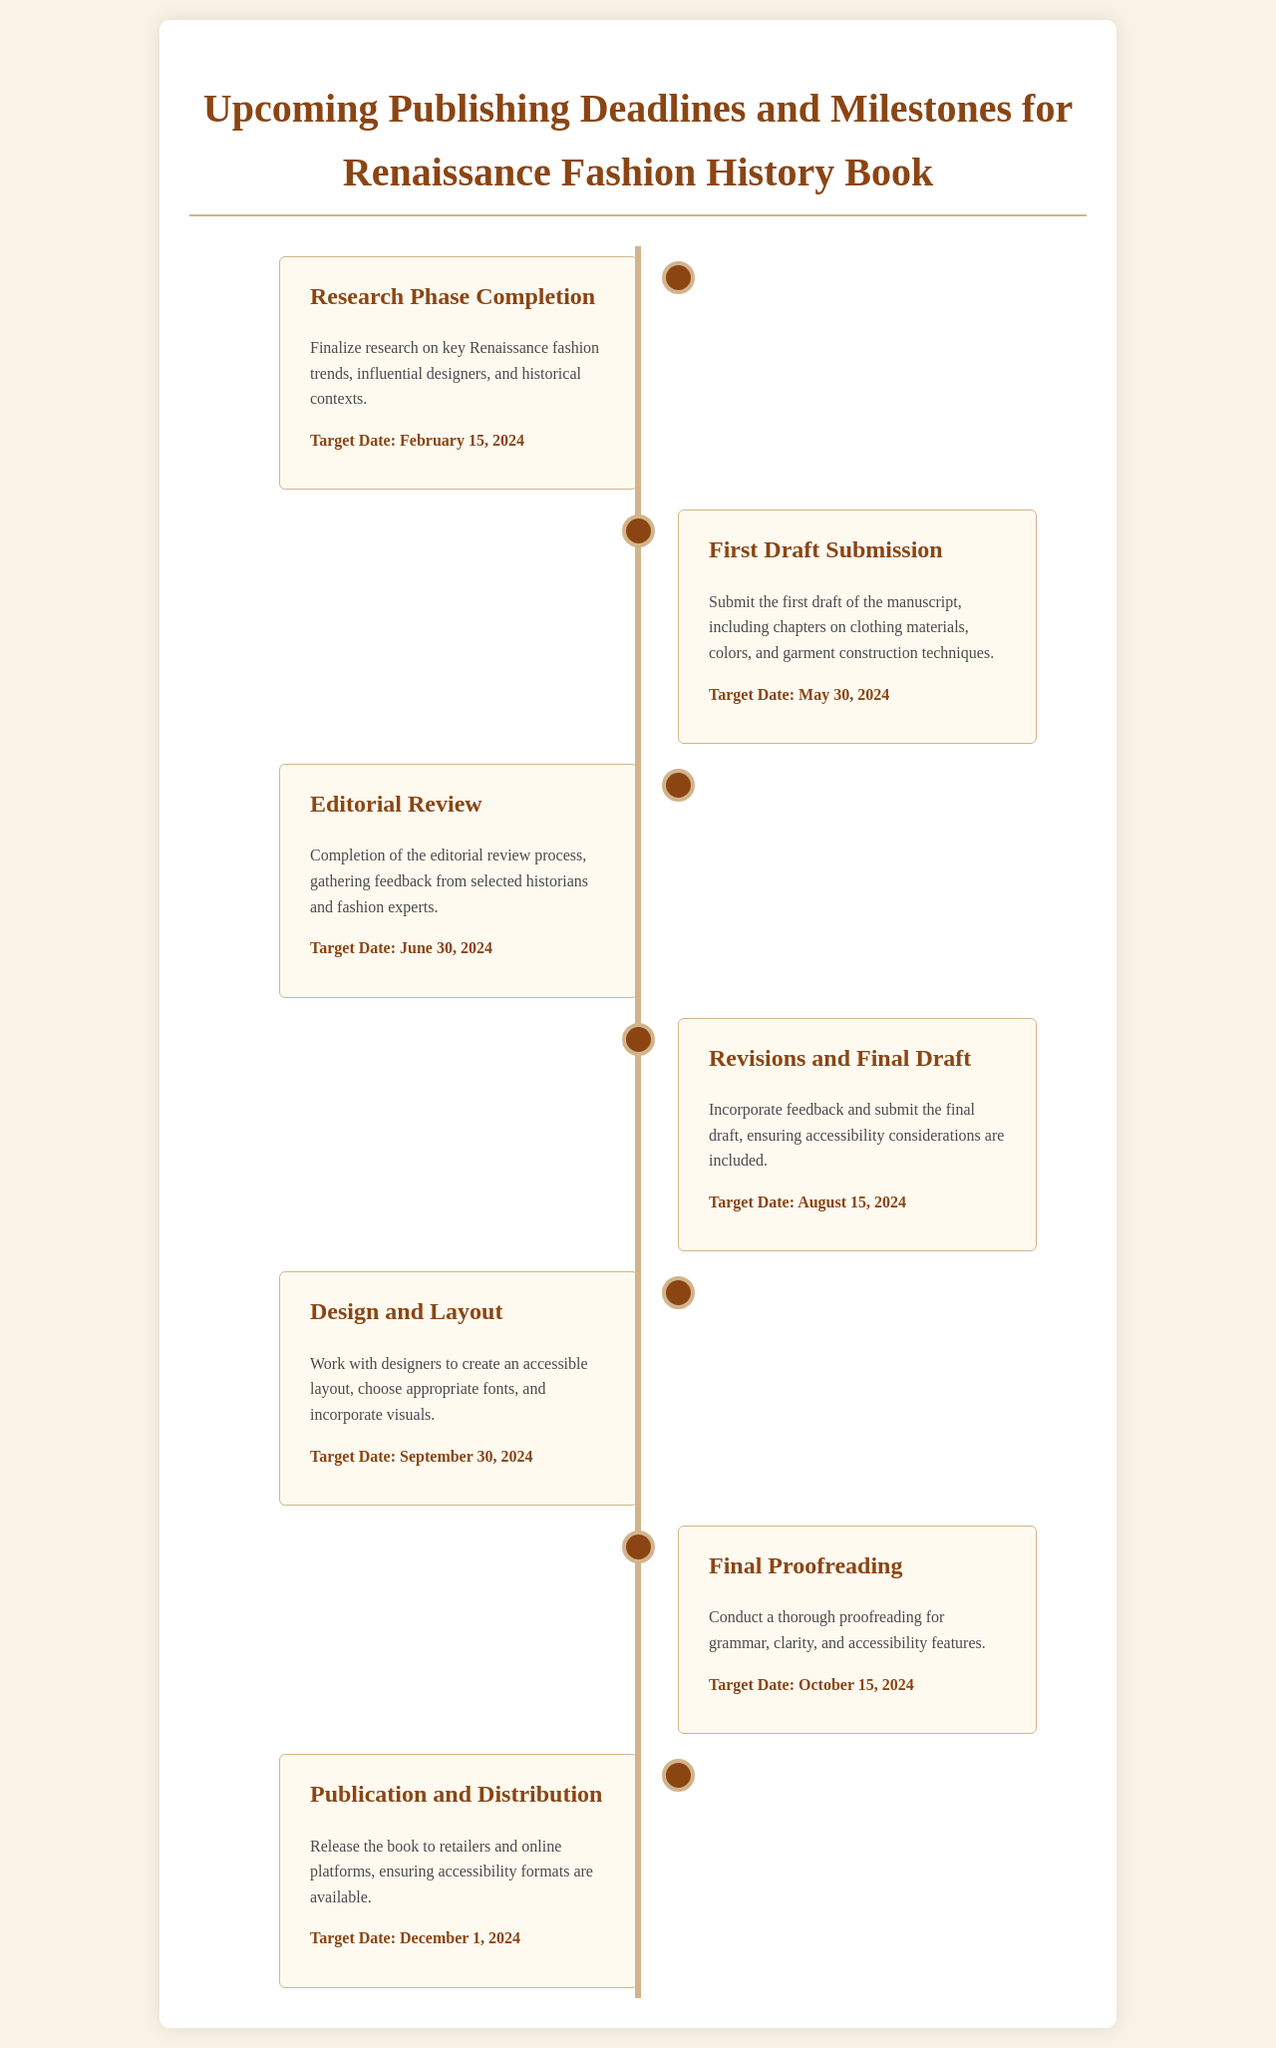What is the target date for Research Phase Completion? The target date for Research Phase Completion is specified in the document as February 15, 2024.
Answer: February 15, 2024 What chapter topics are included in the First Draft Submission? The First Draft Submission includes chapters on clothing materials, colors, and garment construction techniques as mentioned in the document.
Answer: Clothing materials, colors, and garment construction techniques When is the Editorial Review phase scheduled to be completed? The document states that the completion of the Editorial Review process is targeted for June 30, 2024.
Answer: June 30, 2024 What is the outcome expected from the Revisions and Final Draft milestone? The expected outcome from this milestone is to incorporate feedback and submit the final draft, ensuring accessibility considerations are included.
Answer: Incorporate feedback and submit the final draft Which milestone involves working with designers? The milestone that involves working with designers is the Design and Layout phase, as described in the document.
Answer: Design and Layout What is the target date for Final Proofreading? The target date for Final Proofreading is explicitly mentioned in the document as October 15, 2024.
Answer: October 15, 2024 How many days are there between the First Draft Submission and the Editorial Review completion? To determine the days, we calculate between May 30, 2024, and June 30, 2024, which is 31 days.
Answer: 31 days What is the final milestone in the publishing schedule? The final milestone in the publishing schedule is Publication and Distribution, as outlined at the end of the document.
Answer: Publication and Distribution What significant features will the publication ensure are available? The publication will ensure that accessibility formats are available, as noted in the Publication and Distribution milestone.
Answer: Accessibility formats 